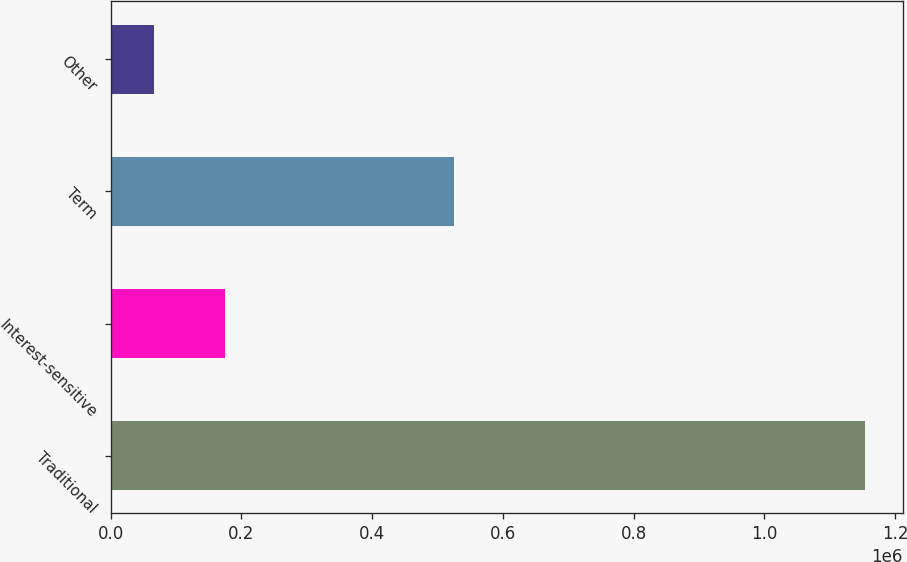Convert chart. <chart><loc_0><loc_0><loc_500><loc_500><bar_chart><fcel>Traditional<fcel>Interest-sensitive<fcel>Term<fcel>Other<nl><fcel>1.15362e+06<fcel>175183<fcel>524784<fcel>66468<nl></chart> 